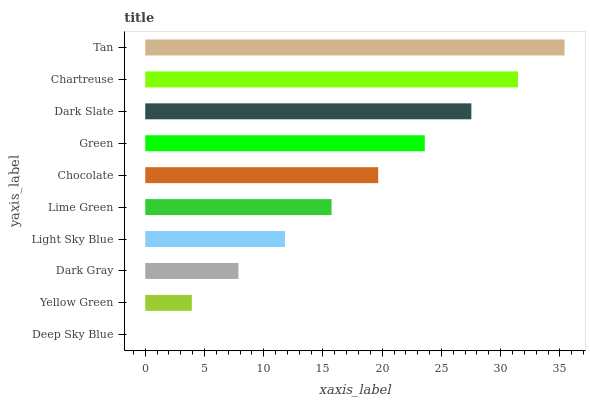Is Deep Sky Blue the minimum?
Answer yes or no. Yes. Is Tan the maximum?
Answer yes or no. Yes. Is Yellow Green the minimum?
Answer yes or no. No. Is Yellow Green the maximum?
Answer yes or no. No. Is Yellow Green greater than Deep Sky Blue?
Answer yes or no. Yes. Is Deep Sky Blue less than Yellow Green?
Answer yes or no. Yes. Is Deep Sky Blue greater than Yellow Green?
Answer yes or no. No. Is Yellow Green less than Deep Sky Blue?
Answer yes or no. No. Is Chocolate the high median?
Answer yes or no. Yes. Is Lime Green the low median?
Answer yes or no. Yes. Is Deep Sky Blue the high median?
Answer yes or no. No. Is Dark Slate the low median?
Answer yes or no. No. 